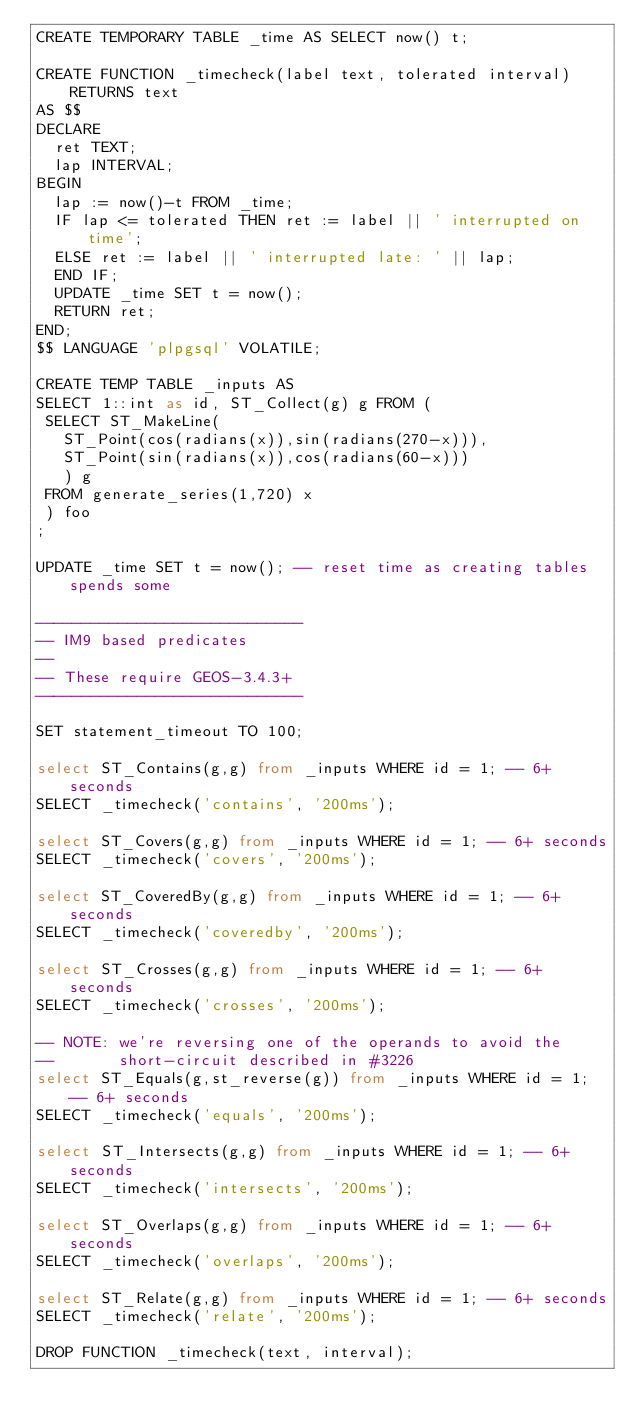Convert code to text. <code><loc_0><loc_0><loc_500><loc_500><_SQL_>CREATE TEMPORARY TABLE _time AS SELECT now() t;

CREATE FUNCTION _timecheck(label text, tolerated interval) RETURNS text
AS $$
DECLARE
  ret TEXT;
  lap INTERVAL;
BEGIN
  lap := now()-t FROM _time;
  IF lap <= tolerated THEN ret := label || ' interrupted on time';
  ELSE ret := label || ' interrupted late: ' || lap;
  END IF;
  UPDATE _time SET t = now();
  RETURN ret;
END;
$$ LANGUAGE 'plpgsql' VOLATILE;

CREATE TEMP TABLE _inputs AS
SELECT 1::int as id, ST_Collect(g) g FROM (
 SELECT ST_MakeLine(
   ST_Point(cos(radians(x)),sin(radians(270-x))),
   ST_Point(sin(radians(x)),cos(radians(60-x)))
   ) g
 FROM generate_series(1,720) x
 ) foo
;

UPDATE _time SET t = now(); -- reset time as creating tables spends some

-----------------------------
-- IM9 based predicates
--
-- These require GEOS-3.4.3+
-----------------------------

SET statement_timeout TO 100;

select ST_Contains(g,g) from _inputs WHERE id = 1; -- 6+ seconds
SELECT _timecheck('contains', '200ms');

select ST_Covers(g,g) from _inputs WHERE id = 1; -- 6+ seconds
SELECT _timecheck('covers', '200ms');

select ST_CoveredBy(g,g) from _inputs WHERE id = 1; -- 6+ seconds
SELECT _timecheck('coveredby', '200ms');

select ST_Crosses(g,g) from _inputs WHERE id = 1; -- 6+ seconds
SELECT _timecheck('crosses', '200ms');

-- NOTE: we're reversing one of the operands to avoid the
--       short-circuit described in #3226
select ST_Equals(g,st_reverse(g)) from _inputs WHERE id = 1; -- 6+ seconds
SELECT _timecheck('equals', '200ms');

select ST_Intersects(g,g) from _inputs WHERE id = 1; -- 6+ seconds
SELECT _timecheck('intersects', '200ms');

select ST_Overlaps(g,g) from _inputs WHERE id = 1; -- 6+ seconds
SELECT _timecheck('overlaps', '200ms');

select ST_Relate(g,g) from _inputs WHERE id = 1; -- 6+ seconds
SELECT _timecheck('relate', '200ms');

DROP FUNCTION _timecheck(text, interval);
</code> 